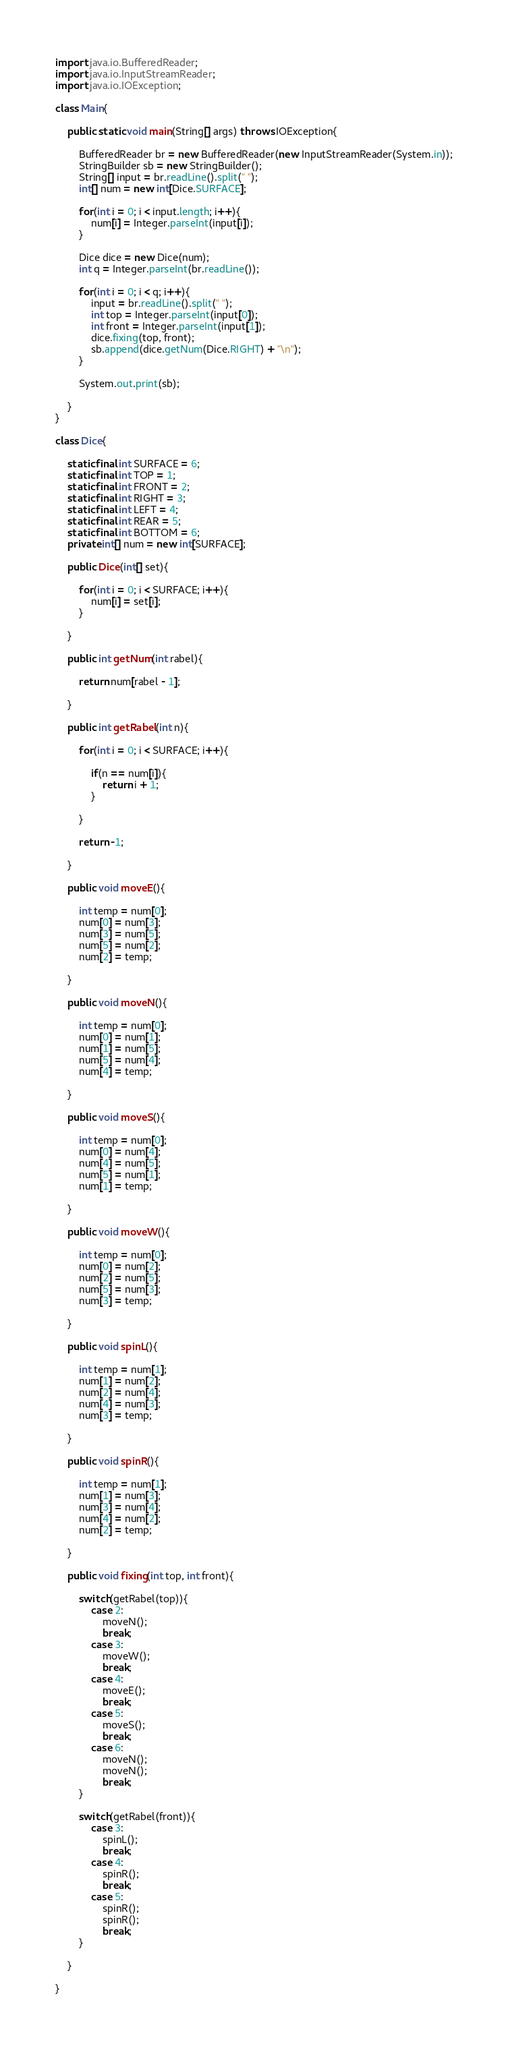Convert code to text. <code><loc_0><loc_0><loc_500><loc_500><_Java_>import java.io.BufferedReader;
import java.io.InputStreamReader;
import java.io.IOException;

class Main{

	public static void main(String[] args) throws IOException{

		BufferedReader br = new BufferedReader(new InputStreamReader(System.in));
		StringBuilder sb = new StringBuilder();
		String[] input = br.readLine().split(" ");
		int[] num = new int[Dice.SURFACE];

		for(int i = 0; i < input.length; i++){
			num[i] = Integer.parseInt(input[i]);
		}

		Dice dice = new Dice(num);
		int q = Integer.parseInt(br.readLine());

		for(int i = 0; i < q; i++){
			input = br.readLine().split(" ");
			int top = Integer.parseInt(input[0]);
			int front = Integer.parseInt(input[1]);
			dice.fixing(top, front);
			sb.append(dice.getNum(Dice.RIGHT) + "\n");
		}

		System.out.print(sb);

	}
}

class Dice{

	static final int SURFACE = 6;
	static final int TOP = 1;
	static final int FRONT = 2;
	static final int RIGHT = 3;
	static final int LEFT = 4;
	static final int REAR = 5;
	static final int BOTTOM = 6;
	private int[] num = new int[SURFACE];

	public Dice(int[] set){

		for(int i = 0; i < SURFACE; i++){
			num[i] = set[i];
		}

	}

	public int getNum(int rabel){

		return num[rabel - 1];

	}

	public int getRabel(int n){

		for(int i = 0; i < SURFACE; i++){

			if(n == num[i]){
				return i + 1;
			}

		}

		return -1;

	}

	public void moveE(){

		int temp = num[0];
		num[0] = num[3];
		num[3] = num[5];
		num[5] = num[2];
		num[2] = temp;

	}

	public void moveN(){

		int temp = num[0];
		num[0] = num[1];
		num[1] = num[5];
		num[5] = num[4];
		num[4] = temp;

	}

	public void moveS(){

		int temp = num[0];
		num[0] = num[4];
		num[4] = num[5];
		num[5] = num[1];
		num[1] = temp;

	}

	public void moveW(){

		int temp = num[0];
		num[0] = num[2];
		num[2] = num[5];
		num[5] = num[3];
		num[3] = temp;

	}

	public void spinL(){

		int temp = num[1];
		num[1] = num[2];
		num[2] = num[4];
		num[4] = num[3];
		num[3] = temp;

	}

	public void spinR(){

		int temp = num[1];
		num[1] = num[3];
		num[3] = num[4];
		num[4] = num[2];
		num[2] = temp;

	}

	public void fixing(int top, int front){

		switch(getRabel(top)){
			case 2:
				moveN();
				break;
			case 3:
				moveW();
				break;
			case 4:
				moveE();
				break;
			case 5:
				moveS();
				break;
			case 6:
				moveN();
				moveN();
				break;
		}

		switch(getRabel(front)){
			case 3:
				spinL();
				break;
			case 4:
				spinR();
				break;
			case 5:
				spinR();
				spinR();
				break;
		}

	}

}</code> 